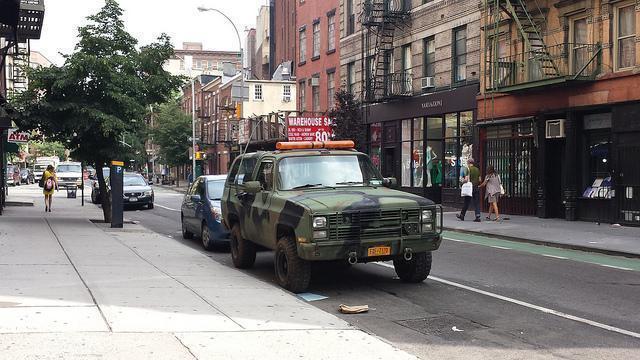Why does the truck have sign on top?
Pick the correct solution from the four options below to address the question.
Options: Original part, vandalism, keep score, advertising. Advertising. 